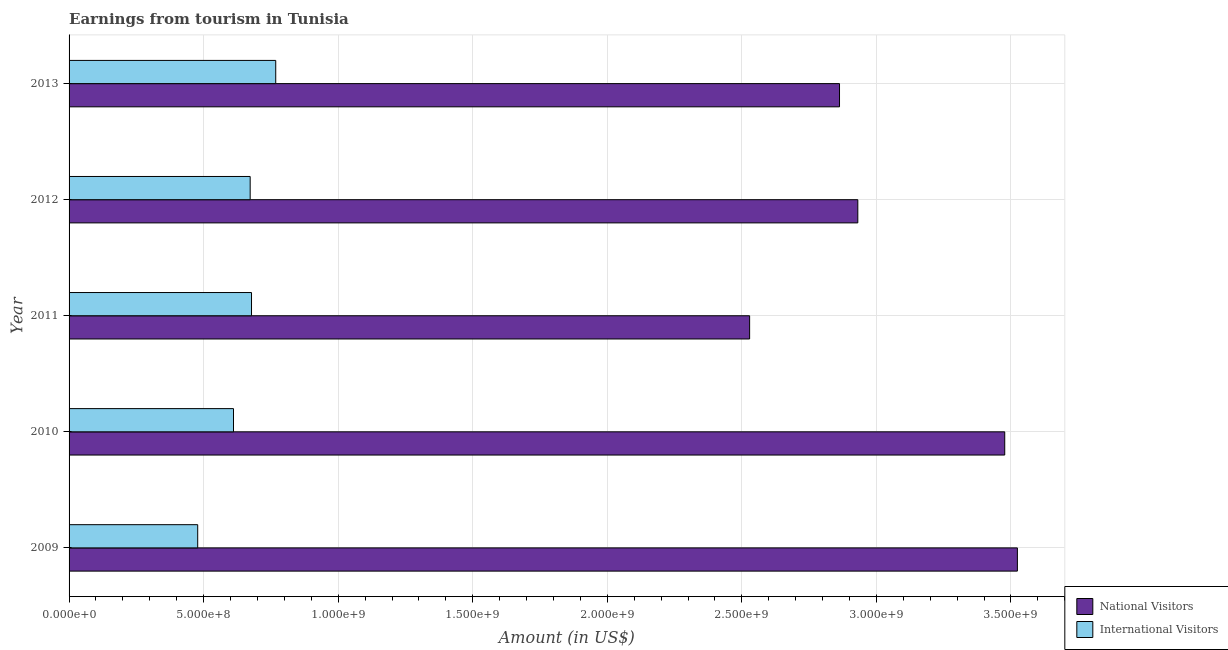How many different coloured bars are there?
Give a very brief answer. 2. How many groups of bars are there?
Offer a terse response. 5. Are the number of bars on each tick of the Y-axis equal?
Give a very brief answer. Yes. How many bars are there on the 4th tick from the top?
Keep it short and to the point. 2. What is the amount earned from national visitors in 2010?
Offer a terse response. 3.48e+09. Across all years, what is the maximum amount earned from national visitors?
Give a very brief answer. 3.52e+09. Across all years, what is the minimum amount earned from national visitors?
Offer a very short reply. 2.53e+09. What is the total amount earned from international visitors in the graph?
Make the answer very short. 3.21e+09. What is the difference between the amount earned from international visitors in 2009 and that in 2013?
Ensure brevity in your answer.  -2.90e+08. What is the difference between the amount earned from international visitors in 2013 and the amount earned from national visitors in 2009?
Make the answer very short. -2.76e+09. What is the average amount earned from national visitors per year?
Offer a very short reply. 3.06e+09. In the year 2013, what is the difference between the amount earned from national visitors and amount earned from international visitors?
Provide a succinct answer. 2.10e+09. What is the ratio of the amount earned from national visitors in 2009 to that in 2011?
Offer a terse response. 1.39. Is the amount earned from international visitors in 2009 less than that in 2010?
Offer a terse response. Yes. What is the difference between the highest and the second highest amount earned from international visitors?
Give a very brief answer. 9.00e+07. What is the difference between the highest and the lowest amount earned from national visitors?
Make the answer very short. 9.95e+08. Is the sum of the amount earned from international visitors in 2010 and 2011 greater than the maximum amount earned from national visitors across all years?
Your answer should be compact. No. What does the 1st bar from the top in 2013 represents?
Your answer should be very brief. International Visitors. What does the 1st bar from the bottom in 2012 represents?
Offer a very short reply. National Visitors. How many bars are there?
Provide a short and direct response. 10. Are all the bars in the graph horizontal?
Provide a succinct answer. Yes. What is the difference between two consecutive major ticks on the X-axis?
Your response must be concise. 5.00e+08. Are the values on the major ticks of X-axis written in scientific E-notation?
Offer a terse response. Yes. Does the graph contain grids?
Provide a short and direct response. Yes. How many legend labels are there?
Keep it short and to the point. 2. How are the legend labels stacked?
Your response must be concise. Vertical. What is the title of the graph?
Keep it short and to the point. Earnings from tourism in Tunisia. Does "Private consumption" appear as one of the legend labels in the graph?
Offer a very short reply. No. What is the label or title of the X-axis?
Your answer should be compact. Amount (in US$). What is the label or title of the Y-axis?
Your answer should be compact. Year. What is the Amount (in US$) of National Visitors in 2009?
Your answer should be very brief. 3.52e+09. What is the Amount (in US$) in International Visitors in 2009?
Give a very brief answer. 4.78e+08. What is the Amount (in US$) of National Visitors in 2010?
Provide a succinct answer. 3.48e+09. What is the Amount (in US$) in International Visitors in 2010?
Provide a succinct answer. 6.11e+08. What is the Amount (in US$) in National Visitors in 2011?
Your answer should be compact. 2.53e+09. What is the Amount (in US$) of International Visitors in 2011?
Keep it short and to the point. 6.78e+08. What is the Amount (in US$) of National Visitors in 2012?
Make the answer very short. 2.93e+09. What is the Amount (in US$) in International Visitors in 2012?
Your answer should be compact. 6.73e+08. What is the Amount (in US$) of National Visitors in 2013?
Offer a very short reply. 2.86e+09. What is the Amount (in US$) in International Visitors in 2013?
Your answer should be very brief. 7.68e+08. Across all years, what is the maximum Amount (in US$) of National Visitors?
Give a very brief answer. 3.52e+09. Across all years, what is the maximum Amount (in US$) in International Visitors?
Keep it short and to the point. 7.68e+08. Across all years, what is the minimum Amount (in US$) in National Visitors?
Your answer should be very brief. 2.53e+09. Across all years, what is the minimum Amount (in US$) of International Visitors?
Give a very brief answer. 4.78e+08. What is the total Amount (in US$) in National Visitors in the graph?
Offer a very short reply. 1.53e+1. What is the total Amount (in US$) in International Visitors in the graph?
Give a very brief answer. 3.21e+09. What is the difference between the Amount (in US$) in National Visitors in 2009 and that in 2010?
Offer a terse response. 4.70e+07. What is the difference between the Amount (in US$) of International Visitors in 2009 and that in 2010?
Your answer should be very brief. -1.33e+08. What is the difference between the Amount (in US$) in National Visitors in 2009 and that in 2011?
Your answer should be very brief. 9.95e+08. What is the difference between the Amount (in US$) in International Visitors in 2009 and that in 2011?
Ensure brevity in your answer.  -2.00e+08. What is the difference between the Amount (in US$) of National Visitors in 2009 and that in 2012?
Provide a short and direct response. 5.93e+08. What is the difference between the Amount (in US$) of International Visitors in 2009 and that in 2012?
Your answer should be very brief. -1.95e+08. What is the difference between the Amount (in US$) of National Visitors in 2009 and that in 2013?
Your answer should be compact. 6.61e+08. What is the difference between the Amount (in US$) in International Visitors in 2009 and that in 2013?
Provide a succinct answer. -2.90e+08. What is the difference between the Amount (in US$) in National Visitors in 2010 and that in 2011?
Your answer should be very brief. 9.48e+08. What is the difference between the Amount (in US$) of International Visitors in 2010 and that in 2011?
Your response must be concise. -6.70e+07. What is the difference between the Amount (in US$) in National Visitors in 2010 and that in 2012?
Your answer should be very brief. 5.46e+08. What is the difference between the Amount (in US$) of International Visitors in 2010 and that in 2012?
Offer a terse response. -6.20e+07. What is the difference between the Amount (in US$) in National Visitors in 2010 and that in 2013?
Make the answer very short. 6.14e+08. What is the difference between the Amount (in US$) of International Visitors in 2010 and that in 2013?
Give a very brief answer. -1.57e+08. What is the difference between the Amount (in US$) of National Visitors in 2011 and that in 2012?
Provide a succinct answer. -4.02e+08. What is the difference between the Amount (in US$) in International Visitors in 2011 and that in 2012?
Your answer should be very brief. 5.00e+06. What is the difference between the Amount (in US$) in National Visitors in 2011 and that in 2013?
Your answer should be compact. -3.34e+08. What is the difference between the Amount (in US$) in International Visitors in 2011 and that in 2013?
Offer a terse response. -9.00e+07. What is the difference between the Amount (in US$) in National Visitors in 2012 and that in 2013?
Offer a very short reply. 6.80e+07. What is the difference between the Amount (in US$) of International Visitors in 2012 and that in 2013?
Your answer should be very brief. -9.50e+07. What is the difference between the Amount (in US$) in National Visitors in 2009 and the Amount (in US$) in International Visitors in 2010?
Your answer should be very brief. 2.91e+09. What is the difference between the Amount (in US$) in National Visitors in 2009 and the Amount (in US$) in International Visitors in 2011?
Provide a succinct answer. 2.85e+09. What is the difference between the Amount (in US$) in National Visitors in 2009 and the Amount (in US$) in International Visitors in 2012?
Provide a succinct answer. 2.85e+09. What is the difference between the Amount (in US$) of National Visitors in 2009 and the Amount (in US$) of International Visitors in 2013?
Offer a terse response. 2.76e+09. What is the difference between the Amount (in US$) in National Visitors in 2010 and the Amount (in US$) in International Visitors in 2011?
Your response must be concise. 2.80e+09. What is the difference between the Amount (in US$) in National Visitors in 2010 and the Amount (in US$) in International Visitors in 2012?
Offer a very short reply. 2.80e+09. What is the difference between the Amount (in US$) of National Visitors in 2010 and the Amount (in US$) of International Visitors in 2013?
Keep it short and to the point. 2.71e+09. What is the difference between the Amount (in US$) in National Visitors in 2011 and the Amount (in US$) in International Visitors in 2012?
Make the answer very short. 1.86e+09. What is the difference between the Amount (in US$) in National Visitors in 2011 and the Amount (in US$) in International Visitors in 2013?
Provide a short and direct response. 1.76e+09. What is the difference between the Amount (in US$) of National Visitors in 2012 and the Amount (in US$) of International Visitors in 2013?
Make the answer very short. 2.16e+09. What is the average Amount (in US$) of National Visitors per year?
Your answer should be very brief. 3.06e+09. What is the average Amount (in US$) in International Visitors per year?
Give a very brief answer. 6.42e+08. In the year 2009, what is the difference between the Amount (in US$) in National Visitors and Amount (in US$) in International Visitors?
Offer a terse response. 3.05e+09. In the year 2010, what is the difference between the Amount (in US$) in National Visitors and Amount (in US$) in International Visitors?
Ensure brevity in your answer.  2.87e+09. In the year 2011, what is the difference between the Amount (in US$) of National Visitors and Amount (in US$) of International Visitors?
Give a very brief answer. 1.85e+09. In the year 2012, what is the difference between the Amount (in US$) in National Visitors and Amount (in US$) in International Visitors?
Provide a succinct answer. 2.26e+09. In the year 2013, what is the difference between the Amount (in US$) of National Visitors and Amount (in US$) of International Visitors?
Offer a terse response. 2.10e+09. What is the ratio of the Amount (in US$) in National Visitors in 2009 to that in 2010?
Keep it short and to the point. 1.01. What is the ratio of the Amount (in US$) in International Visitors in 2009 to that in 2010?
Offer a very short reply. 0.78. What is the ratio of the Amount (in US$) of National Visitors in 2009 to that in 2011?
Give a very brief answer. 1.39. What is the ratio of the Amount (in US$) in International Visitors in 2009 to that in 2011?
Keep it short and to the point. 0.7. What is the ratio of the Amount (in US$) of National Visitors in 2009 to that in 2012?
Keep it short and to the point. 1.2. What is the ratio of the Amount (in US$) of International Visitors in 2009 to that in 2012?
Offer a terse response. 0.71. What is the ratio of the Amount (in US$) in National Visitors in 2009 to that in 2013?
Offer a very short reply. 1.23. What is the ratio of the Amount (in US$) in International Visitors in 2009 to that in 2013?
Provide a succinct answer. 0.62. What is the ratio of the Amount (in US$) in National Visitors in 2010 to that in 2011?
Keep it short and to the point. 1.37. What is the ratio of the Amount (in US$) of International Visitors in 2010 to that in 2011?
Provide a short and direct response. 0.9. What is the ratio of the Amount (in US$) of National Visitors in 2010 to that in 2012?
Ensure brevity in your answer.  1.19. What is the ratio of the Amount (in US$) of International Visitors in 2010 to that in 2012?
Provide a succinct answer. 0.91. What is the ratio of the Amount (in US$) of National Visitors in 2010 to that in 2013?
Provide a short and direct response. 1.21. What is the ratio of the Amount (in US$) in International Visitors in 2010 to that in 2013?
Provide a succinct answer. 0.8. What is the ratio of the Amount (in US$) in National Visitors in 2011 to that in 2012?
Your answer should be compact. 0.86. What is the ratio of the Amount (in US$) in International Visitors in 2011 to that in 2012?
Offer a very short reply. 1.01. What is the ratio of the Amount (in US$) in National Visitors in 2011 to that in 2013?
Your answer should be compact. 0.88. What is the ratio of the Amount (in US$) in International Visitors in 2011 to that in 2013?
Provide a short and direct response. 0.88. What is the ratio of the Amount (in US$) in National Visitors in 2012 to that in 2013?
Your answer should be compact. 1.02. What is the ratio of the Amount (in US$) of International Visitors in 2012 to that in 2013?
Ensure brevity in your answer.  0.88. What is the difference between the highest and the second highest Amount (in US$) in National Visitors?
Your response must be concise. 4.70e+07. What is the difference between the highest and the second highest Amount (in US$) of International Visitors?
Make the answer very short. 9.00e+07. What is the difference between the highest and the lowest Amount (in US$) in National Visitors?
Ensure brevity in your answer.  9.95e+08. What is the difference between the highest and the lowest Amount (in US$) of International Visitors?
Give a very brief answer. 2.90e+08. 